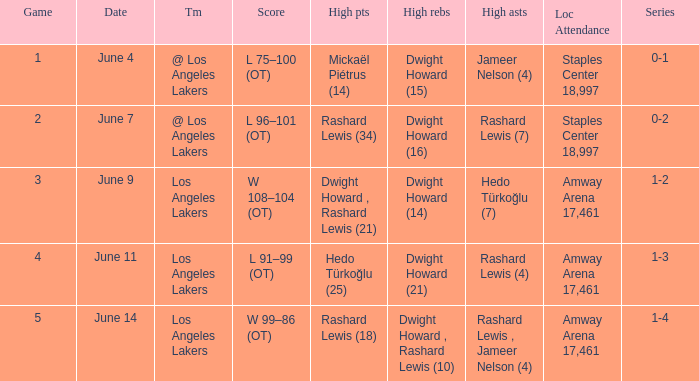What is the highest Game, when High Assists is "Hedo Türkoğlu (7)"? 3.0. 